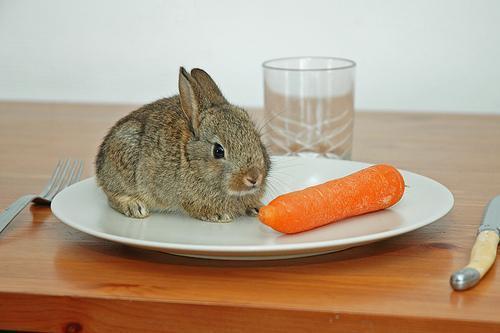How many carrots are there?
Give a very brief answer. 1. 